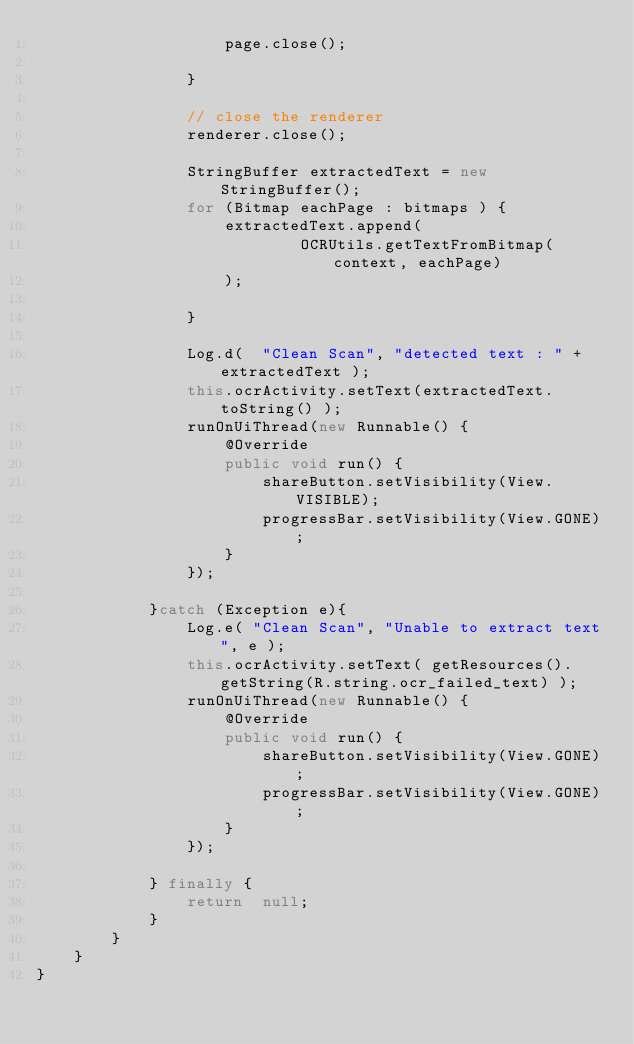<code> <loc_0><loc_0><loc_500><loc_500><_Java_>                    page.close();

                }

                // close the renderer
                renderer.close();

                StringBuffer extractedText = new StringBuffer();
                for (Bitmap eachPage : bitmaps ) {
                    extractedText.append(
                            OCRUtils.getTextFromBitmap(context, eachPage)
                    );

                }

                Log.d(  "Clean Scan", "detected text : " + extractedText );
                this.ocrActivity.setText(extractedText.toString() );
                runOnUiThread(new Runnable() {
                    @Override
                    public void run() {
                        shareButton.setVisibility(View.VISIBLE);
                        progressBar.setVisibility(View.GONE);
                    }
                });

            }catch (Exception e){
                Log.e( "Clean Scan", "Unable to extract text", e );
                this.ocrActivity.setText( getResources().getString(R.string.ocr_failed_text) );
                runOnUiThread(new Runnable() {
                    @Override
                    public void run() {
                        shareButton.setVisibility(View.GONE);
                        progressBar.setVisibility(View.GONE);
                    }
                });

            } finally {
                return  null;
            }
        }
    }
}
</code> 